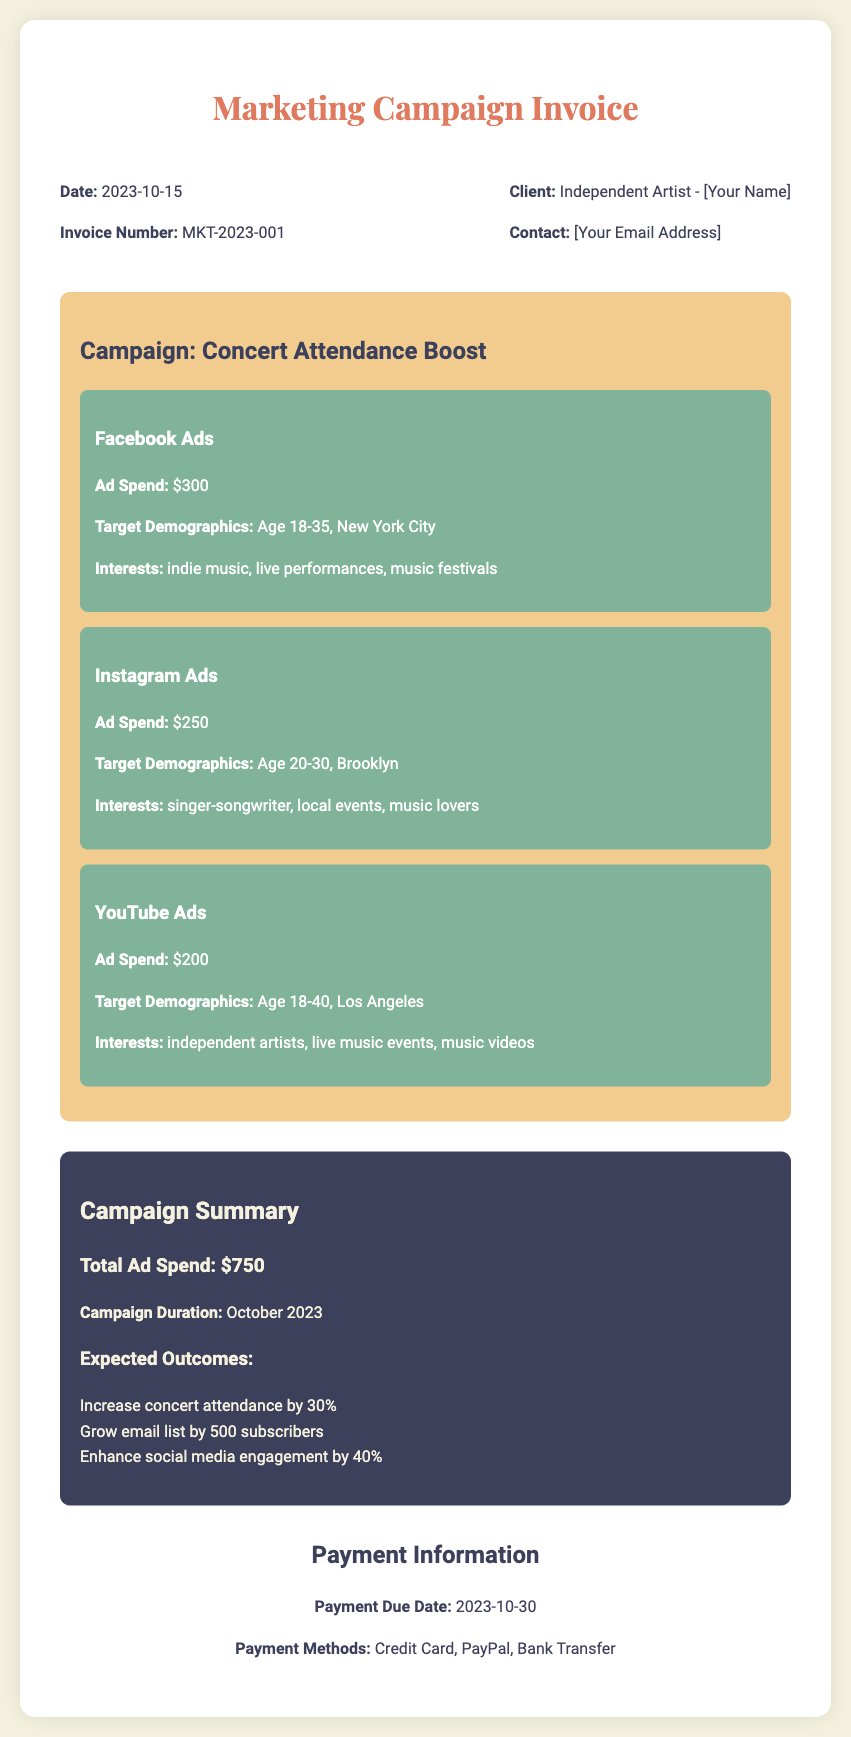what is the invoice number? The invoice number is listed near the top of the document, identifying the specific invoice.
Answer: MKT-2023-001 what is the total ad spend? The total ad spend is calculated based on the individual ad spends listed within the campaign details.
Answer: $750 what is the campaign title? The campaign title is mentioned prominently in the campaign details section, indicating the focus of the marketing effort.
Answer: Concert Attendance Boost what demographic is targeted by Facebook Ads? The demographic targeted by Facebook Ads is specified in the ad details, highlighting the age range and location.
Answer: Age 18-35, New York City when is the payment due date? The payment due date is stated in the payment information section, indicating when payment is expected.
Answer: 2023-10-30 how much is allocated for Instagram Ads? The allocation for Instagram Ads can be found in the campaign details, showing the expenditure for this specific platform.
Answer: $250 what are the expected outcomes of the campaign? The expected outcomes are listed in the summary section, outlining the goals of the campaign.
Answer: Increase concert attendance by 30% which payment methods are available? The available payment methods are detailed in the payment information section, specifying how payments can be made.
Answer: Credit Card, PayPal, Bank Transfer what is the campaign duration? The campaign duration is noted in the summary section, specifying the time frame for the marketing efforts.
Answer: October 2023 